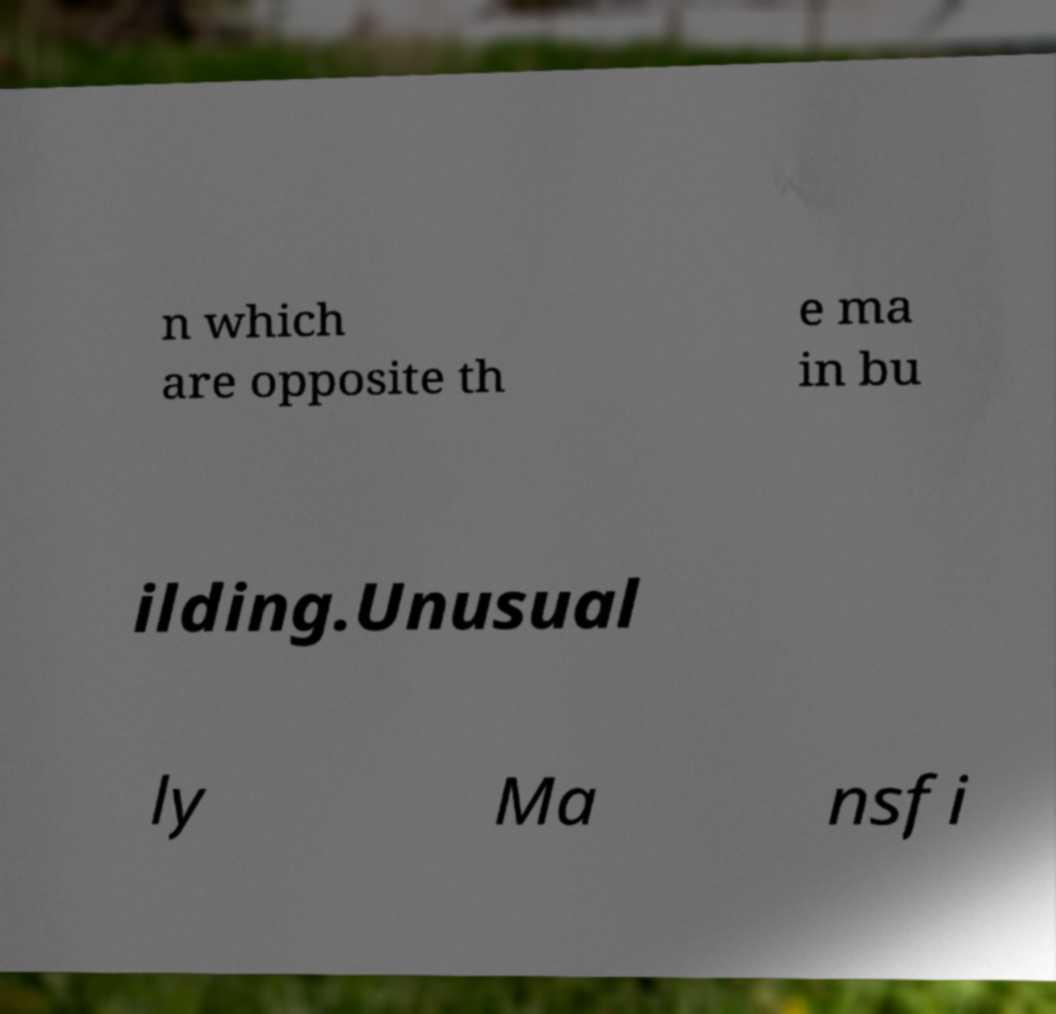Could you assist in decoding the text presented in this image and type it out clearly? n which are opposite th e ma in bu ilding.Unusual ly Ma nsfi 